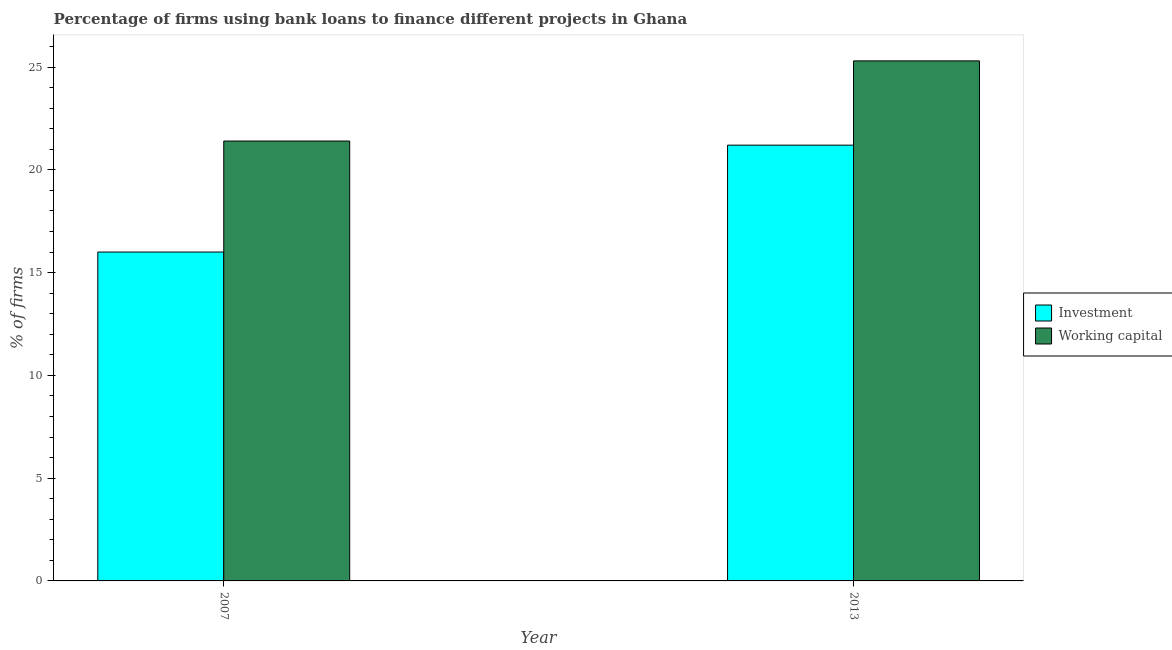How many groups of bars are there?
Offer a very short reply. 2. How many bars are there on the 1st tick from the left?
Provide a short and direct response. 2. How many bars are there on the 2nd tick from the right?
Your answer should be very brief. 2. What is the label of the 2nd group of bars from the left?
Provide a succinct answer. 2013. What is the percentage of firms using banks to finance working capital in 2007?
Provide a short and direct response. 21.4. Across all years, what is the maximum percentage of firms using banks to finance investment?
Your answer should be very brief. 21.2. In which year was the percentage of firms using banks to finance investment minimum?
Make the answer very short. 2007. What is the total percentage of firms using banks to finance working capital in the graph?
Your response must be concise. 46.7. What is the difference between the percentage of firms using banks to finance investment in 2007 and that in 2013?
Your answer should be compact. -5.2. What is the difference between the percentage of firms using banks to finance working capital in 2013 and the percentage of firms using banks to finance investment in 2007?
Your response must be concise. 3.9. What is the average percentage of firms using banks to finance working capital per year?
Provide a short and direct response. 23.35. What is the ratio of the percentage of firms using banks to finance working capital in 2007 to that in 2013?
Your response must be concise. 0.85. In how many years, is the percentage of firms using banks to finance investment greater than the average percentage of firms using banks to finance investment taken over all years?
Provide a succinct answer. 1. What does the 2nd bar from the left in 2013 represents?
Ensure brevity in your answer.  Working capital. What does the 2nd bar from the right in 2013 represents?
Provide a short and direct response. Investment. How many years are there in the graph?
Keep it short and to the point. 2. What is the difference between two consecutive major ticks on the Y-axis?
Provide a short and direct response. 5. Does the graph contain grids?
Ensure brevity in your answer.  No. Where does the legend appear in the graph?
Your response must be concise. Center right. How many legend labels are there?
Your response must be concise. 2. How are the legend labels stacked?
Offer a very short reply. Vertical. What is the title of the graph?
Your answer should be very brief. Percentage of firms using bank loans to finance different projects in Ghana. Does "Exports of goods" appear as one of the legend labels in the graph?
Make the answer very short. No. What is the label or title of the Y-axis?
Your answer should be compact. % of firms. What is the % of firms of Investment in 2007?
Your response must be concise. 16. What is the % of firms of Working capital in 2007?
Provide a short and direct response. 21.4. What is the % of firms of Investment in 2013?
Give a very brief answer. 21.2. What is the % of firms in Working capital in 2013?
Your response must be concise. 25.3. Across all years, what is the maximum % of firms of Investment?
Offer a very short reply. 21.2. Across all years, what is the maximum % of firms in Working capital?
Offer a terse response. 25.3. Across all years, what is the minimum % of firms of Working capital?
Your answer should be very brief. 21.4. What is the total % of firms of Investment in the graph?
Offer a very short reply. 37.2. What is the total % of firms of Working capital in the graph?
Give a very brief answer. 46.7. What is the difference between the % of firms in Investment in 2007 and that in 2013?
Give a very brief answer. -5.2. What is the difference between the % of firms of Working capital in 2007 and that in 2013?
Ensure brevity in your answer.  -3.9. What is the difference between the % of firms in Investment in 2007 and the % of firms in Working capital in 2013?
Ensure brevity in your answer.  -9.3. What is the average % of firms in Working capital per year?
Ensure brevity in your answer.  23.35. What is the ratio of the % of firms of Investment in 2007 to that in 2013?
Keep it short and to the point. 0.75. What is the ratio of the % of firms in Working capital in 2007 to that in 2013?
Your answer should be very brief. 0.85. What is the difference between the highest and the second highest % of firms of Investment?
Make the answer very short. 5.2. What is the difference between the highest and the lowest % of firms of Investment?
Keep it short and to the point. 5.2. What is the difference between the highest and the lowest % of firms of Working capital?
Provide a short and direct response. 3.9. 